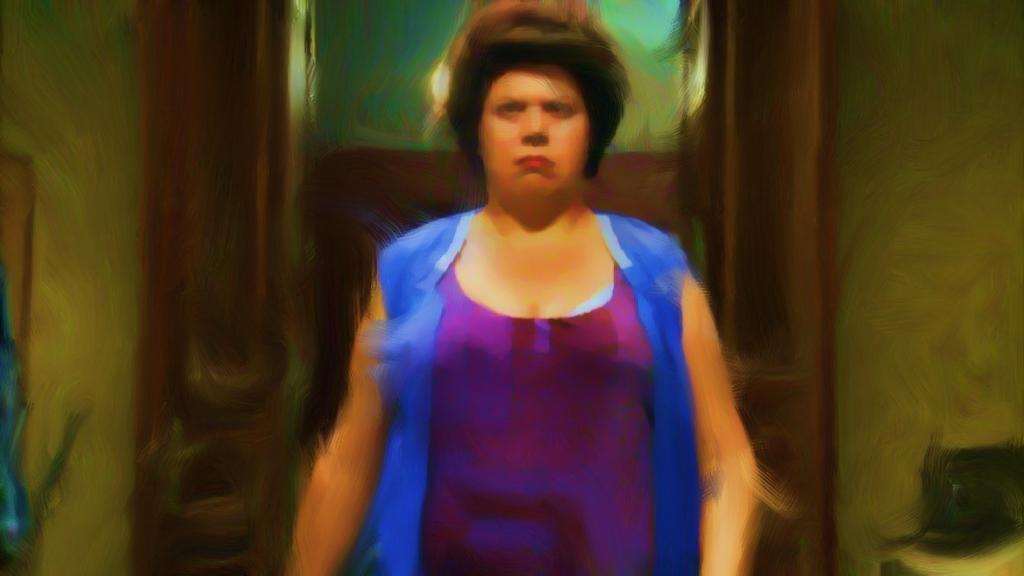Who is present in the image? There is a woman in the image. What is the woman wearing? The woman is wearing a blue dress. What can be seen in the background of the image? There is a door and a wall in the background of the image. Can you tell if the image has been altered in any way? The image may have been edited. What type of account does the woman have in the image? There is no indication of any account in the image; it simply features a woman wearing a blue dress with a door and a wall in the background. 